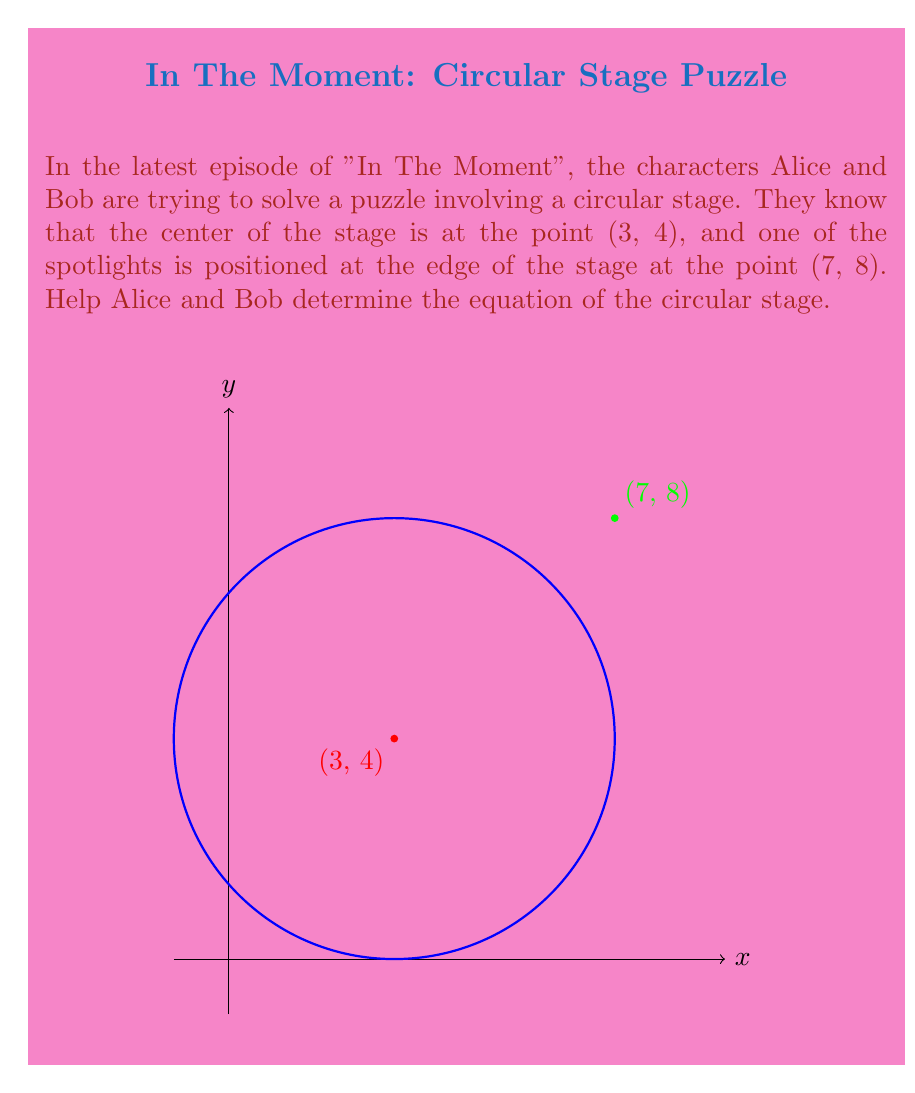What is the answer to this math problem? Let's approach this step-by-step:

1) The general equation of a circle is:
   $$(x-h)^2 + (y-k)^2 = r^2$$
   where (h,k) is the center and r is the radius.

2) We're given that the center is at (3,4), so h=3 and k=4.

3) To find r, we need to calculate the distance between the center (3,4) and the point on the circumference (7,8).

4) We can use the distance formula:
   $$r = \sqrt{(x_2-x_1)^2 + (y_2-y_1)^2}$$
   $$r = \sqrt{(7-3)^2 + (8-4)^2}$$
   $$r = \sqrt{4^2 + 4^2} = \sqrt{32} = 4\sqrt{2}$$

5) Now we have all the components to write the equation:
   $$(x-3)^2 + (y-4)^2 = (4\sqrt{2})^2$$

6) Simplify the right side:
   $$(x-3)^2 + (y-4)^2 = 32$$

This is the equation of the circular stage.
Answer: $$(x-3)^2 + (y-4)^2 = 32$$ 